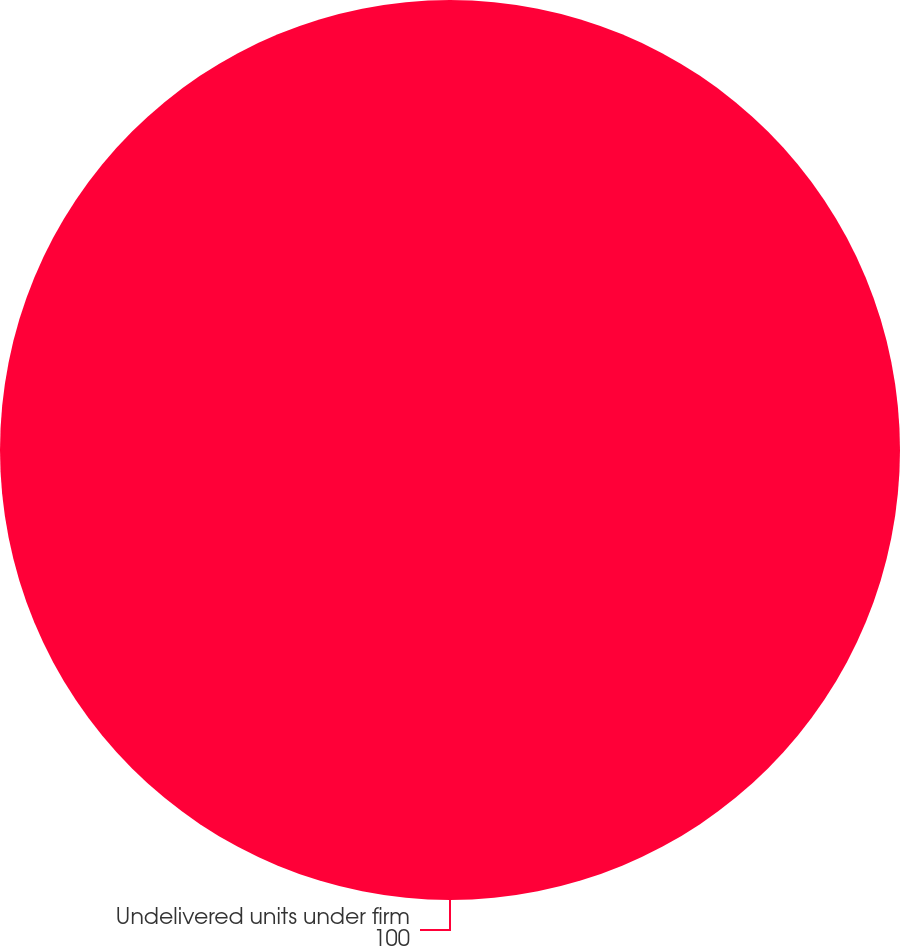<chart> <loc_0><loc_0><loc_500><loc_500><pie_chart><fcel>Undelivered units under firm<nl><fcel>100.0%<nl></chart> 